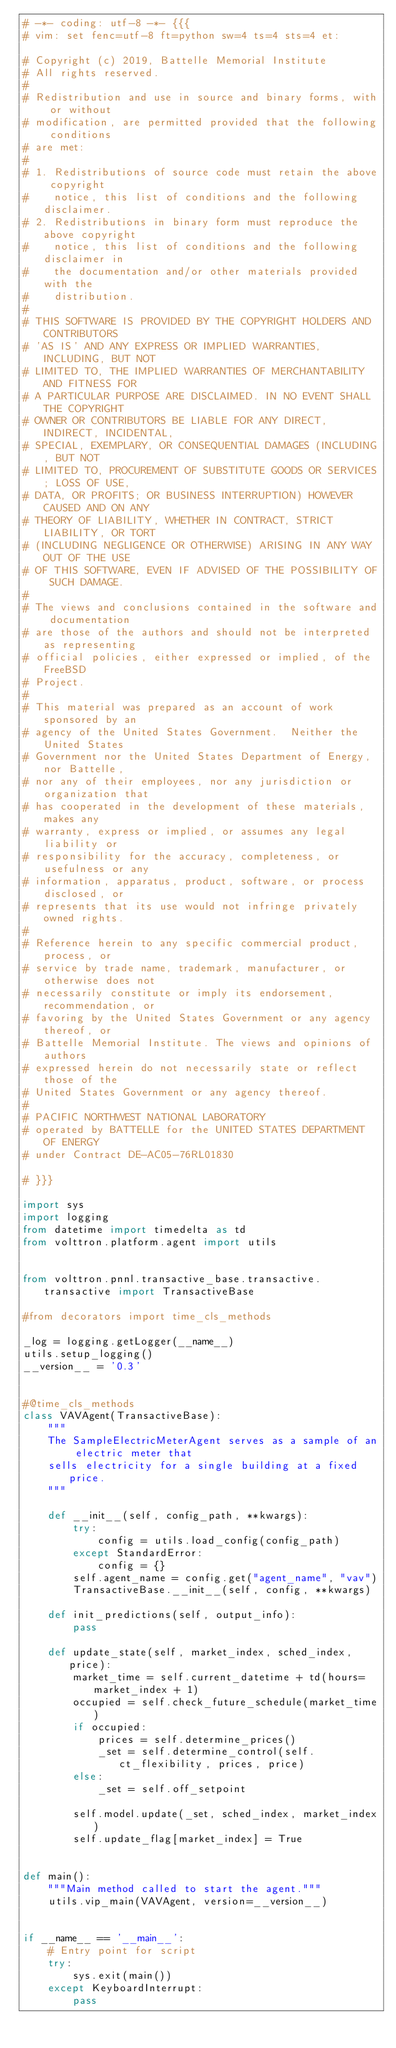<code> <loc_0><loc_0><loc_500><loc_500><_Python_># -*- coding: utf-8 -*- {{{
# vim: set fenc=utf-8 ft=python sw=4 ts=4 sts=4 et:

# Copyright (c) 2019, Battelle Memorial Institute
# All rights reserved.
#
# Redistribution and use in source and binary forms, with or without
# modification, are permitted provided that the following conditions
# are met:
#
# 1. Redistributions of source code must retain the above copyright
#    notice, this list of conditions and the following disclaimer.
# 2. Redistributions in binary form must reproduce the above copyright
#    notice, this list of conditions and the following disclaimer in
#    the documentation and/or other materials provided with the
#    distribution.
#
# THIS SOFTWARE IS PROVIDED BY THE COPYRIGHT HOLDERS AND CONTRIBUTORS
# 'AS IS' AND ANY EXPRESS OR IMPLIED WARRANTIES, INCLUDING, BUT NOT
# LIMITED TO, THE IMPLIED WARRANTIES OF MERCHANTABILITY AND FITNESS FOR
# A PARTICULAR PURPOSE ARE DISCLAIMED. IN NO EVENT SHALL THE COPYRIGHT
# OWNER OR CONTRIBUTORS BE LIABLE FOR ANY DIRECT, INDIRECT, INCIDENTAL,
# SPECIAL, EXEMPLARY, OR CONSEQUENTIAL DAMAGES (INCLUDING, BUT NOT
# LIMITED TO, PROCUREMENT OF SUBSTITUTE GOODS OR SERVICES; LOSS OF USE,
# DATA, OR PROFITS; OR BUSINESS INTERRUPTION) HOWEVER CAUSED AND ON ANY
# THEORY OF LIABILITY, WHETHER IN CONTRACT, STRICT LIABILITY, OR TORT
# (INCLUDING NEGLIGENCE OR OTHERWISE) ARISING IN ANY WAY OUT OF THE USE
# OF THIS SOFTWARE, EVEN IF ADVISED OF THE POSSIBILITY OF SUCH DAMAGE.
#
# The views and conclusions contained in the software and documentation
# are those of the authors and should not be interpreted as representing
# official policies, either expressed or implied, of the FreeBSD
# Project.
#
# This material was prepared as an account of work sponsored by an
# agency of the United States Government.  Neither the United States
# Government nor the United States Department of Energy, nor Battelle,
# nor any of their employees, nor any jurisdiction or organization that
# has cooperated in the development of these materials, makes any
# warranty, express or implied, or assumes any legal liability or
# responsibility for the accuracy, completeness, or usefulness or any
# information, apparatus, product, software, or process disclosed, or
# represents that its use would not infringe privately owned rights.
#
# Reference herein to any specific commercial product, process, or
# service by trade name, trademark, manufacturer, or otherwise does not
# necessarily constitute or imply its endorsement, recommendation, or
# favoring by the United States Government or any agency thereof, or
# Battelle Memorial Institute. The views and opinions of authors
# expressed herein do not necessarily state or reflect those of the
# United States Government or any agency thereof.
#
# PACIFIC NORTHWEST NATIONAL LABORATORY
# operated by BATTELLE for the UNITED STATES DEPARTMENT OF ENERGY
# under Contract DE-AC05-76RL01830

# }}}

import sys
import logging
from datetime import timedelta as td
from volttron.platform.agent import utils


from volttron.pnnl.transactive_base.transactive.transactive import TransactiveBase

#from decorators import time_cls_methods

_log = logging.getLogger(__name__)
utils.setup_logging()
__version__ = '0.3'


#@time_cls_methods
class VAVAgent(TransactiveBase):
    """
    The SampleElectricMeterAgent serves as a sample of an electric meter that
    sells electricity for a single building at a fixed price.
    """

    def __init__(self, config_path, **kwargs):
        try:
            config = utils.load_config(config_path)
        except StandardError:
            config = {}
        self.agent_name = config.get("agent_name", "vav")
        TransactiveBase.__init__(self, config, **kwargs)

    def init_predictions(self, output_info):
        pass

    def update_state(self, market_index, sched_index, price):
        market_time = self.current_datetime + td(hours=market_index + 1)
        occupied = self.check_future_schedule(market_time)
        if occupied:
            prices = self.determine_prices()
            _set = self.determine_control(self.ct_flexibility, prices, price)
        else:
            _set = self.off_setpoint

        self.model.update(_set, sched_index, market_index)
        self.update_flag[market_index] = True


def main():
    """Main method called to start the agent."""
    utils.vip_main(VAVAgent, version=__version__)


if __name__ == '__main__':
    # Entry point for script
    try:
        sys.exit(main())
    except KeyboardInterrupt:
        pass
</code> 